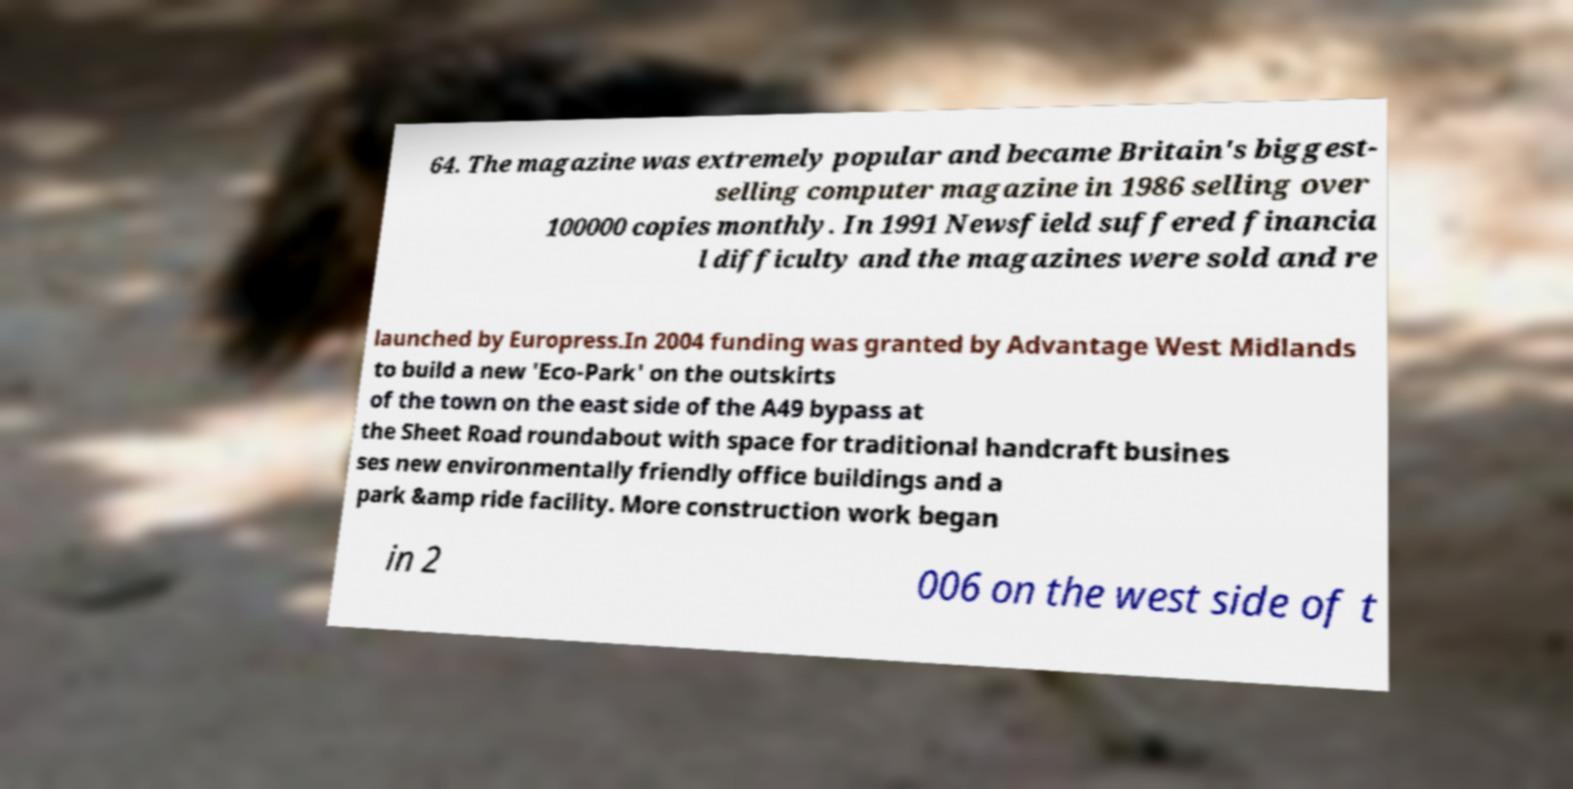Please read and relay the text visible in this image. What does it say? 64. The magazine was extremely popular and became Britain's biggest- selling computer magazine in 1986 selling over 100000 copies monthly. In 1991 Newsfield suffered financia l difficulty and the magazines were sold and re launched by Europress.In 2004 funding was granted by Advantage West Midlands to build a new 'Eco-Park' on the outskirts of the town on the east side of the A49 bypass at the Sheet Road roundabout with space for traditional handcraft busines ses new environmentally friendly office buildings and a park &amp ride facility. More construction work began in 2 006 on the west side of t 